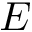Convert formula to latex. <formula><loc_0><loc_0><loc_500><loc_500>E</formula> 